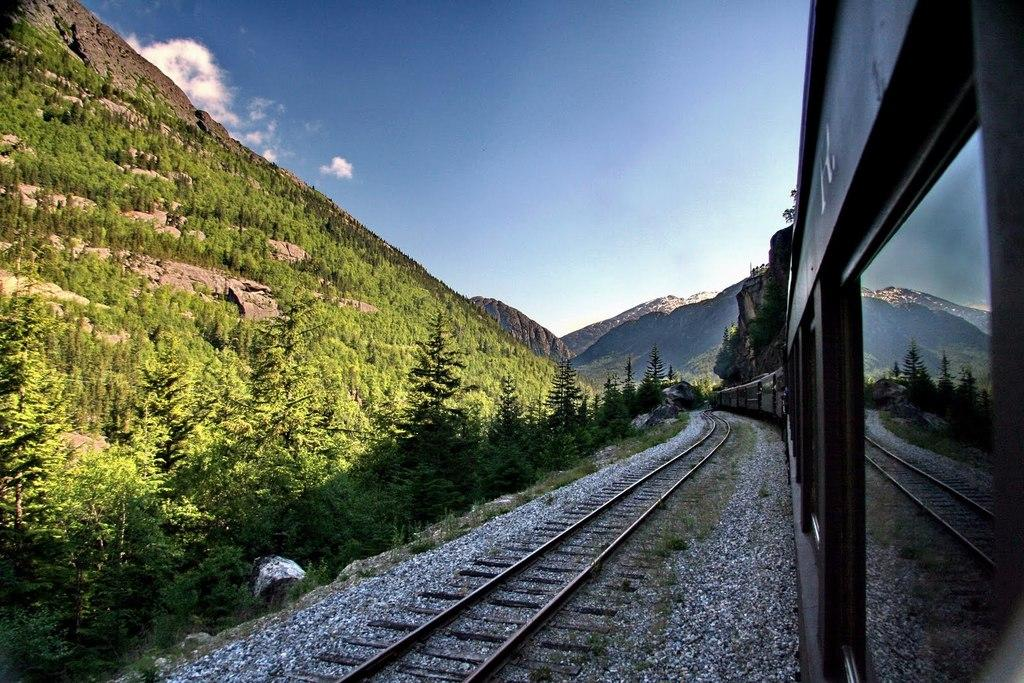What is the main subject of the image? The main subject of the image is a train on the track. What type of terrain can be seen in the image? There are stones, plants, a group of trees, and hills visible in the image. What is the condition of the sky in the image? The sky is cloudy in the image. What industry is represented by the fact in the image? There is no specific industry represented in the image; it simply shows a train on a track and the surrounding environment. What value can be assigned to the stones in the image? The value of the stones in the image cannot be determined, as they are not being sold or traded. 